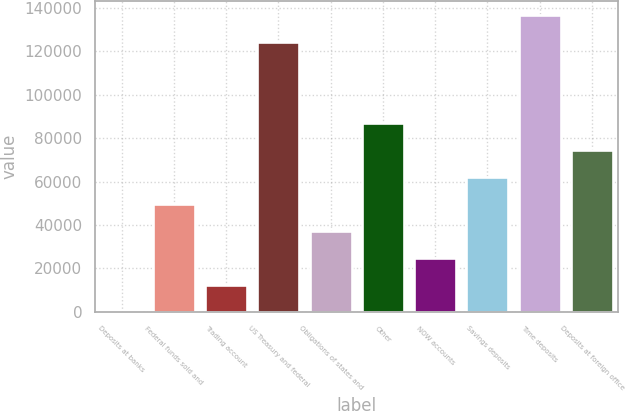Convert chart. <chart><loc_0><loc_0><loc_500><loc_500><bar_chart><fcel>Deposits at banks<fcel>Federal funds sold and<fcel>Trading account<fcel>US Treasury and federal<fcel>Obligations of states and<fcel>Other<fcel>NOW accounts<fcel>Savings deposits<fcel>Time deposits<fcel>Deposits at foreign office<nl><fcel>39<fcel>49707.8<fcel>12456.2<fcel>124211<fcel>37290.6<fcel>86959.4<fcel>24873.4<fcel>62125<fcel>136628<fcel>74542.2<nl></chart> 